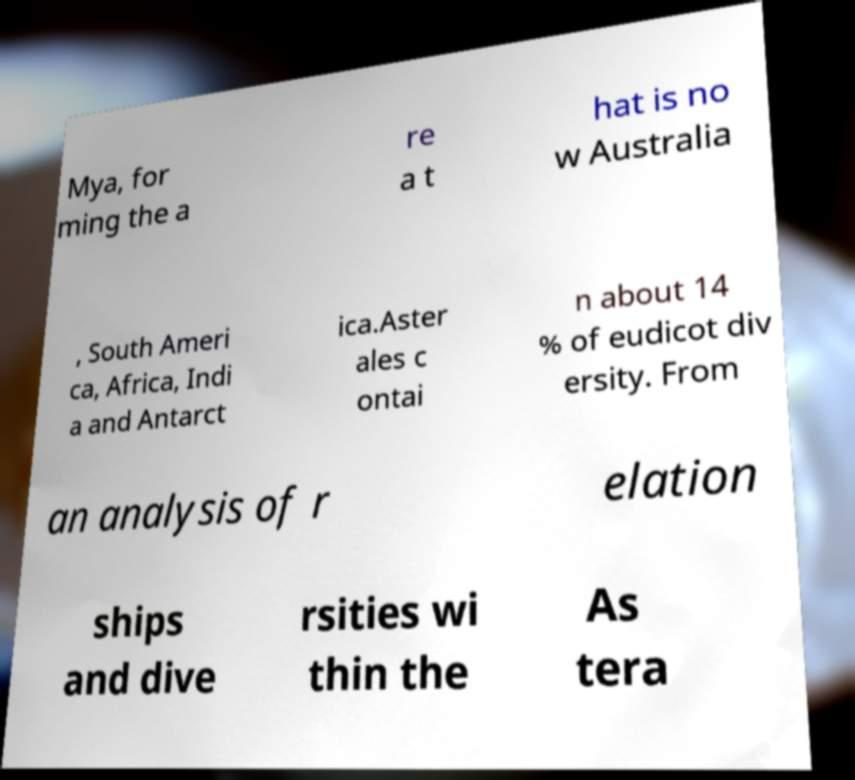Can you accurately transcribe the text from the provided image for me? Mya, for ming the a re a t hat is no w Australia , South Ameri ca, Africa, Indi a and Antarct ica.Aster ales c ontai n about 14 % of eudicot div ersity. From an analysis of r elation ships and dive rsities wi thin the As tera 